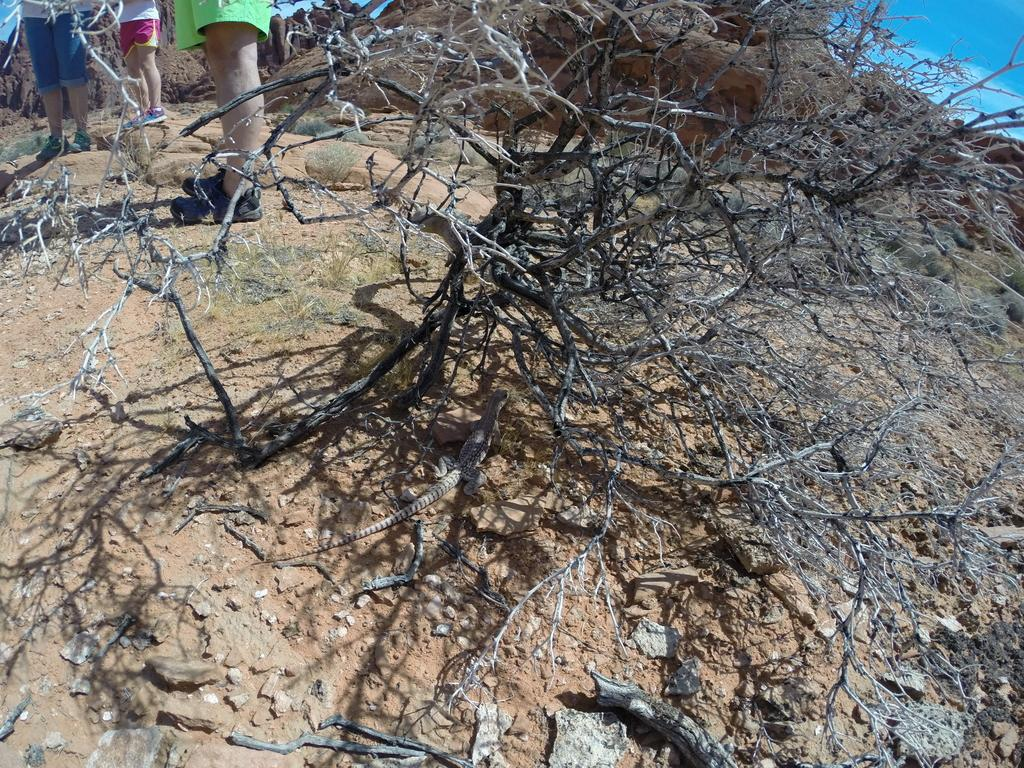What type of plant can be seen in the image? There is a dry plant in the image. Can you describe any other living organisms in the image? Yes, there is a lizard in the middle of the image. Are there any human elements in the image? Yes, there are legs of a person visible in the top left of the image. How does the hook help the lizard maintain its balance in the image? There is no hook present in the image, and therefore no such assistance can be observed. 